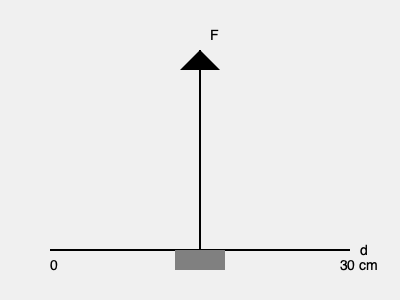During a resistance training session, a physiotherapist applies a constant force F perpendicular to a lever arm attached to a muscle group. If the work done is 60 joules and the lever arm rotates through an arc length of 30 cm, what is the magnitude of the force F applied? To solve this problem, we'll use the relationship between work, force, and displacement:

1) The formula for work is: $W = F \cdot d$
   Where W is work, F is force, and d is displacement

2) We're given:
   - Work (W) = 60 joules
   - Displacement (d) = 30 cm = 0.3 m (converting to SI units)

3) Substituting these values into the formula:
   $60 \text{ J} = F \cdot 0.3 \text{ m}$

4) To find F, we divide both sides by 0.3 m:
   $F = \frac{60 \text{ J}}{0.3 \text{ m}} = 200 \text{ N}$

Therefore, the magnitude of the force F applied is 200 Newtons.
Answer: 200 N 